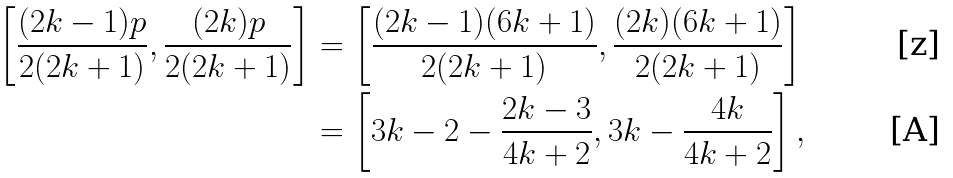<formula> <loc_0><loc_0><loc_500><loc_500>\left [ \frac { ( 2 k - 1 ) p } { 2 ( 2 k + 1 ) } , \frac { ( 2 k ) p } { 2 ( 2 k + 1 ) } \right ] & = \left [ \frac { ( 2 k - 1 ) ( 6 k + 1 ) } { 2 ( 2 k + 1 ) } , \frac { ( 2 k ) ( 6 k + 1 ) } { 2 ( 2 k + 1 ) } \right ] \\ & = \left [ 3 k - 2 - \frac { 2 k - 3 } { 4 k + 2 } , 3 k - \frac { 4 k } { 4 k + 2 } \right ] ,</formula> 